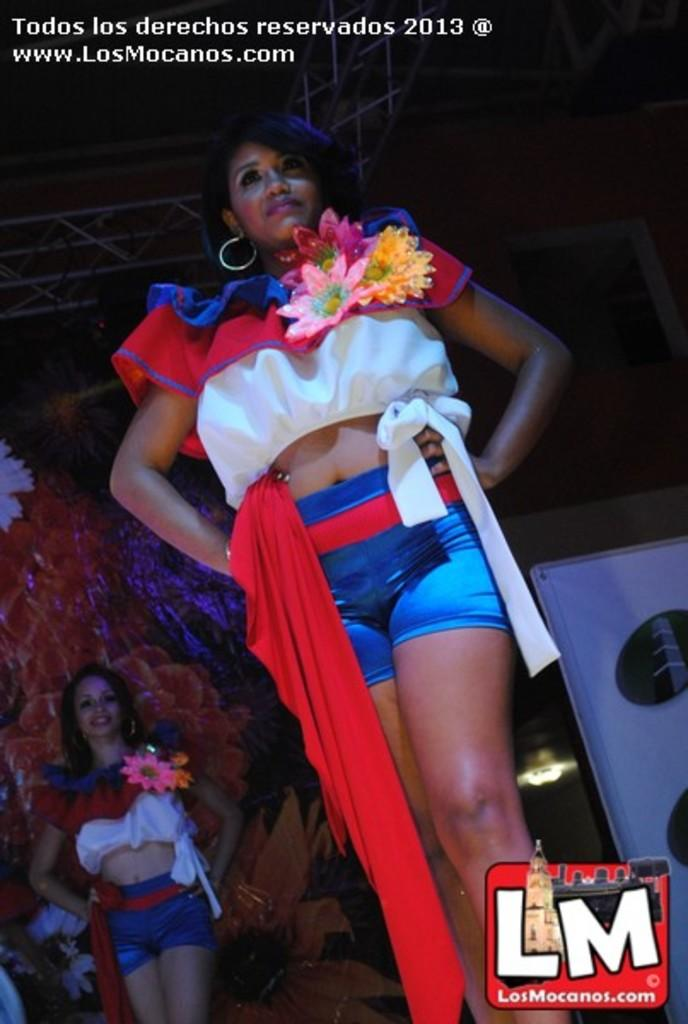<image>
Share a concise interpretation of the image provided. the picture is copy right by the website www.LosMocanos.com 